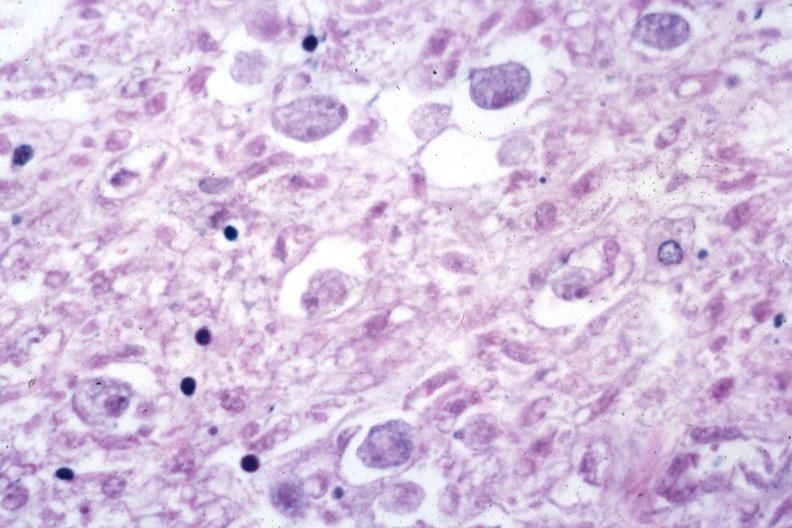s intrauterine contraceptive device present?
Answer the question using a single word or phrase. No 